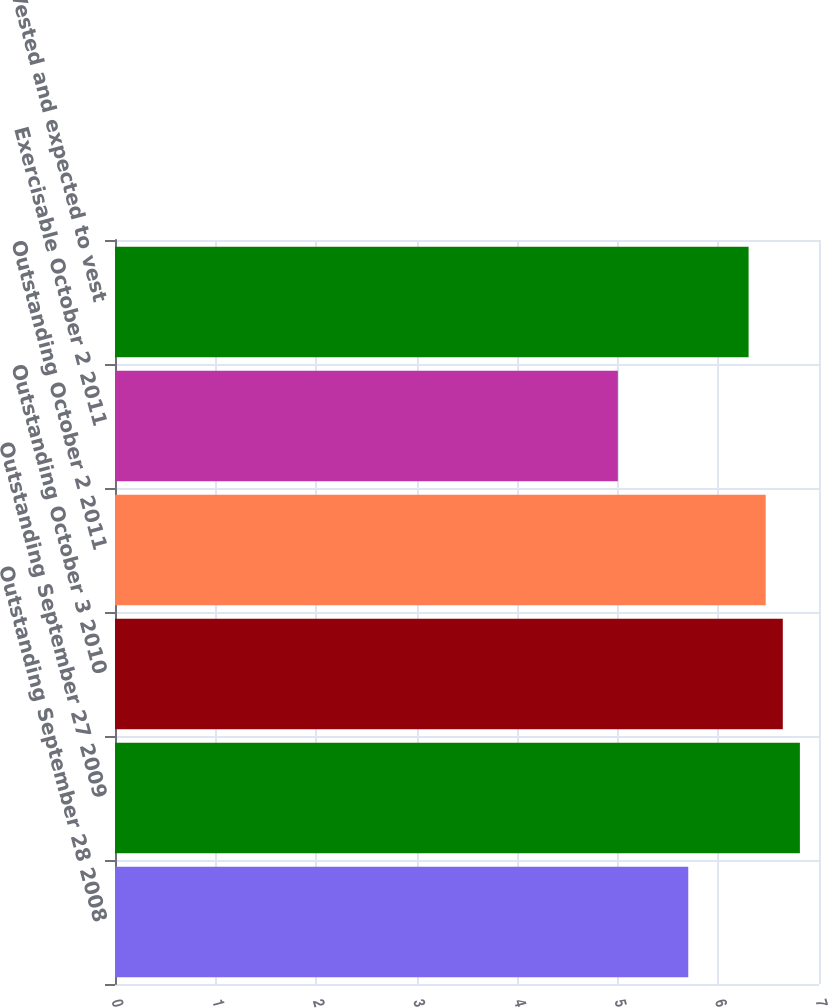Convert chart to OTSL. <chart><loc_0><loc_0><loc_500><loc_500><bar_chart><fcel>Outstanding September 28 2008<fcel>Outstanding September 27 2009<fcel>Outstanding October 3 2010<fcel>Outstanding October 2 2011<fcel>Exercisable October 2 2011<fcel>Vested and expected to vest<nl><fcel>5.7<fcel>6.81<fcel>6.64<fcel>6.47<fcel>5<fcel>6.3<nl></chart> 